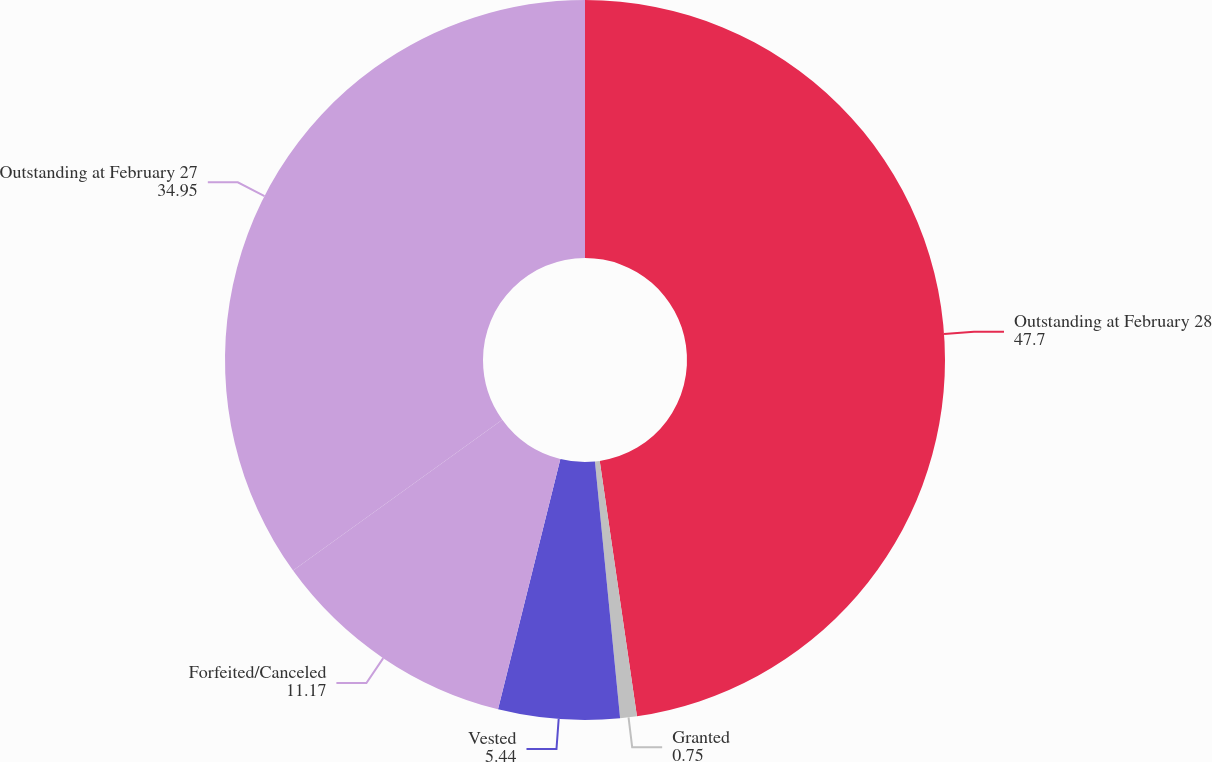Convert chart. <chart><loc_0><loc_0><loc_500><loc_500><pie_chart><fcel>Outstanding at February 28<fcel>Granted<fcel>Vested<fcel>Forfeited/Canceled<fcel>Outstanding at February 27<nl><fcel>47.7%<fcel>0.75%<fcel>5.44%<fcel>11.17%<fcel>34.95%<nl></chart> 